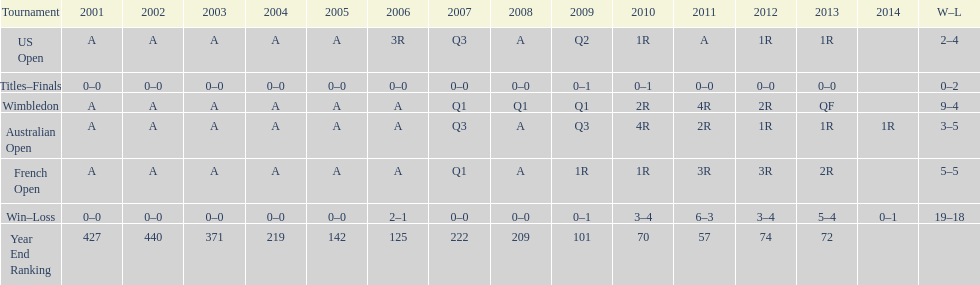Parse the table in full. {'header': ['Tournament', '2001', '2002', '2003', '2004', '2005', '2006', '2007', '2008', '2009', '2010', '2011', '2012', '2013', '2014', 'W–L'], 'rows': [['US Open', 'A', 'A', 'A', 'A', 'A', '3R', 'Q3', 'A', 'Q2', '1R', 'A', '1R', '1R', '', '2–4'], ['Titles–Finals', '0–0', '0–0', '0–0', '0–0', '0–0', '0–0', '0–0', '0–0', '0–1', '0–1', '0–0', '0–0', '0–0', '', '0–2'], ['Wimbledon', 'A', 'A', 'A', 'A', 'A', 'A', 'Q1', 'Q1', 'Q1', '2R', '4R', '2R', 'QF', '', '9–4'], ['Australian Open', 'A', 'A', 'A', 'A', 'A', 'A', 'Q3', 'A', 'Q3', '4R', '2R', '1R', '1R', '1R', '3–5'], ['French Open', 'A', 'A', 'A', 'A', 'A', 'A', 'Q1', 'A', '1R', '1R', '3R', '3R', '2R', '', '5–5'], ['Win–Loss', '0–0', '0–0', '0–0', '0–0', '0–0', '2–1', '0–0', '0–0', '0–1', '3–4', '6–3', '3–4', '5–4', '0–1', '19–18'], ['Year End Ranking', '427', '440', '371', '219', '142', '125', '222', '209', '101', '70', '57', '74', '72', '', '']]} In which years were there only 1 loss? 2006, 2009, 2014. 